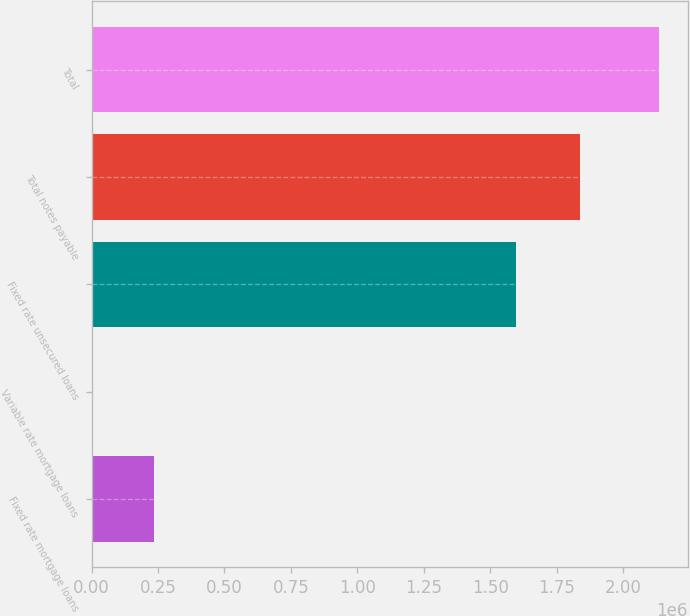Convert chart to OTSL. <chart><loc_0><loc_0><loc_500><loc_500><bar_chart><fcel>Fixed rate mortgage loans<fcel>Variable rate mortgage loans<fcel>Fixed rate unsecured loans<fcel>Total notes payable<fcel>Total<nl><fcel>235150<fcel>5130<fcel>1.59762e+06<fcel>1.8379e+06<fcel>2.13557e+06<nl></chart> 